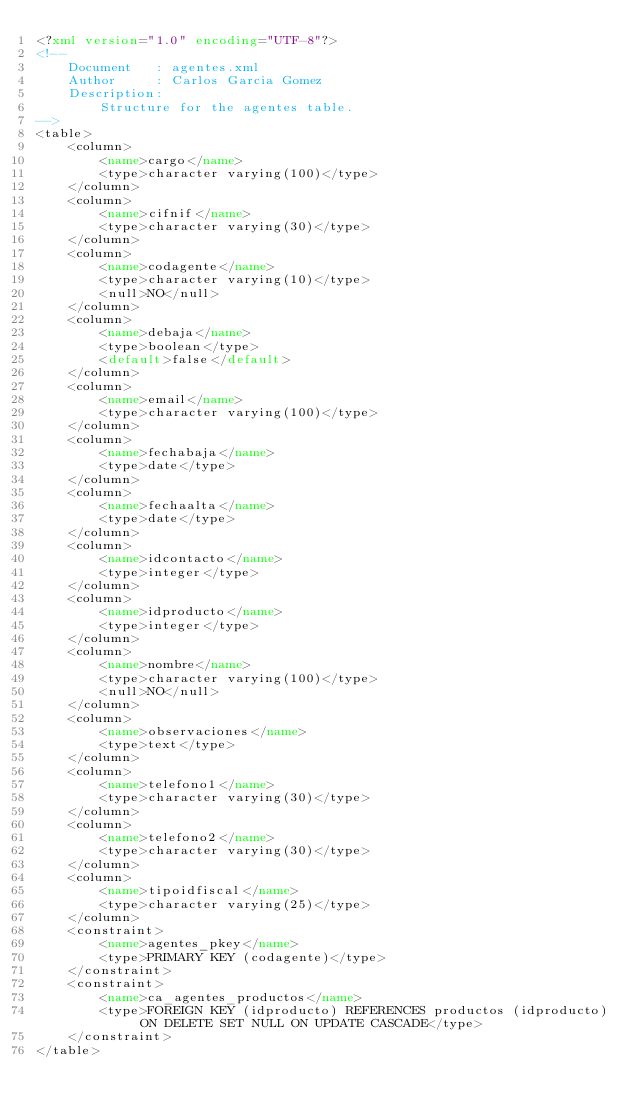<code> <loc_0><loc_0><loc_500><loc_500><_XML_><?xml version="1.0" encoding="UTF-8"?>
<!--
    Document   : agentes.xml
    Author     : Carlos Garcia Gomez
    Description:
        Structure for the agentes table.
-->
<table>
    <column>
        <name>cargo</name>
        <type>character varying(100)</type>
    </column>
    <column>
        <name>cifnif</name>
        <type>character varying(30)</type>
    </column>
    <column>
        <name>codagente</name>
        <type>character varying(10)</type>
        <null>NO</null>
    </column>
    <column>
        <name>debaja</name>
        <type>boolean</type>
        <default>false</default>
    </column>
    <column>
        <name>email</name>
        <type>character varying(100)</type>
    </column>
    <column>
        <name>fechabaja</name>
        <type>date</type>
    </column>
    <column>
        <name>fechaalta</name>
        <type>date</type>
    </column>
    <column>
        <name>idcontacto</name>
        <type>integer</type>
    </column>
    <column>
        <name>idproducto</name>
        <type>integer</type>
    </column>
    <column>
        <name>nombre</name>
        <type>character varying(100)</type>
        <null>NO</null>
    </column>
    <column>
        <name>observaciones</name>
        <type>text</type>
    </column>
    <column>
        <name>telefono1</name>
        <type>character varying(30)</type>
    </column>
    <column>
        <name>telefono2</name>
        <type>character varying(30)</type>
    </column>
    <column>
        <name>tipoidfiscal</name>
        <type>character varying(25)</type>
    </column>
    <constraint>
        <name>agentes_pkey</name>
        <type>PRIMARY KEY (codagente)</type>
    </constraint>
    <constraint>
        <name>ca_agentes_productos</name>
        <type>FOREIGN KEY (idproducto) REFERENCES productos (idproducto) ON DELETE SET NULL ON UPDATE CASCADE</type>
    </constraint>
</table>
</code> 